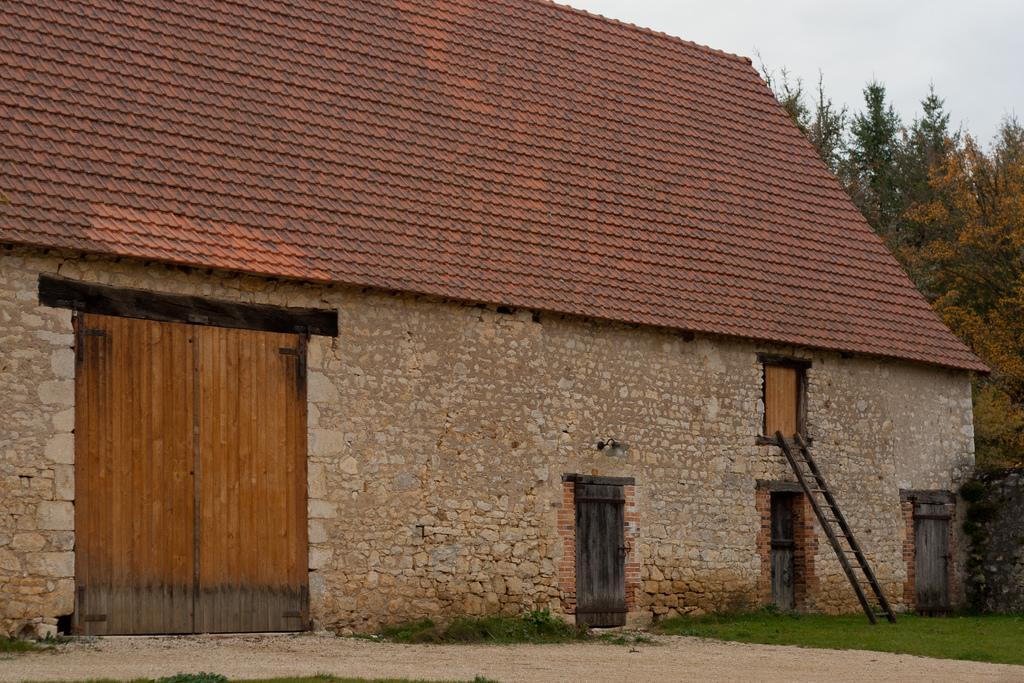What type of structure is visible in the image? There is a house in the image. What object can be seen near the house? There is a ladder in the image. What type of vegetation is present in the image? There is grass in the image. What type of surface can be seen in the image? There is a path in the image. What architectural feature is present in the image? There is a wall in the image. What type of natural elements are visible in the image? There are trees in the image. What part of the natural environment is visible in the image? The sky is visible in the image. What type of cup is being used to water the trees in the image? There is no cup present in the image, nor is there any indication of watering the trees. What color is the shirt worn by the tree in the image? Trees do not wear shirts, and there is no tree depicted as wearing clothing in the image. 